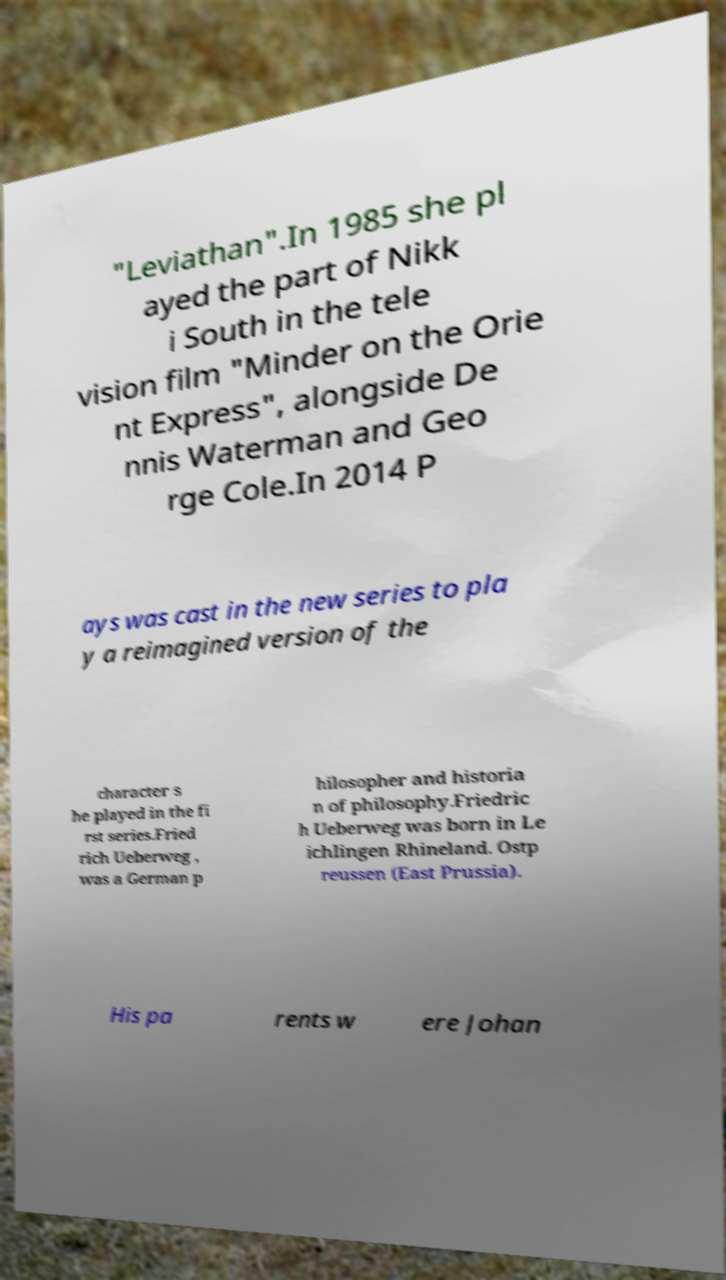Please identify and transcribe the text found in this image. "Leviathan".In 1985 she pl ayed the part of Nikk i South in the tele vision film "Minder on the Orie nt Express", alongside De nnis Waterman and Geo rge Cole.In 2014 P ays was cast in the new series to pla y a reimagined version of the character s he played in the fi rst series.Fried rich Ueberweg , was a German p hilosopher and historia n of philosophy.Friedric h Ueberweg was born in Le ichlingen Rhineland. Ostp reussen (East Prussia). His pa rents w ere Johan 